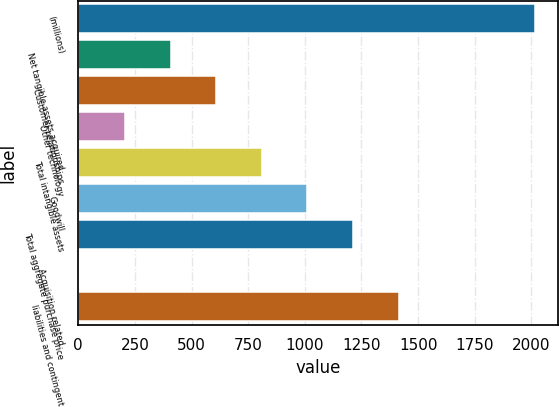<chart> <loc_0><loc_0><loc_500><loc_500><bar_chart><fcel>(millions)<fcel>Net tangible assets acquired<fcel>Customer relationships<fcel>Other technology<fcel>Total intangible assets<fcel>Goodwill<fcel>Total aggregate purchase price<fcel>Acquisition related<fcel>liabilities and contingent<nl><fcel>2017<fcel>407.88<fcel>609.02<fcel>206.74<fcel>810.16<fcel>1011.3<fcel>1212.44<fcel>5.6<fcel>1413.58<nl></chart> 